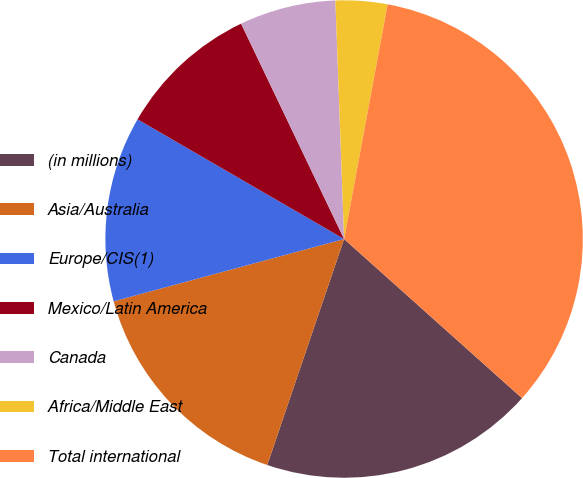<chart> <loc_0><loc_0><loc_500><loc_500><pie_chart><fcel>(in millions)<fcel>Asia/Australia<fcel>Europe/CIS(1)<fcel>Mexico/Latin America<fcel>Canada<fcel>Africa/Middle East<fcel>Total international<nl><fcel>18.6%<fcel>15.58%<fcel>12.56%<fcel>9.54%<fcel>6.52%<fcel>3.5%<fcel>33.69%<nl></chart> 